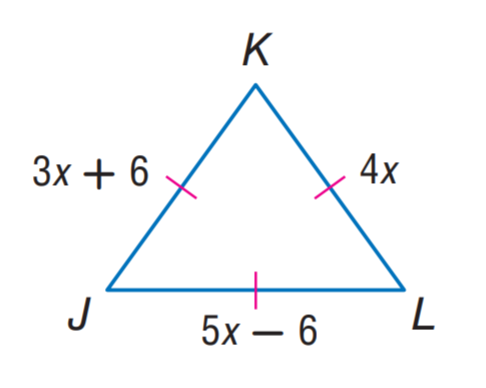Answer the mathemtical geometry problem and directly provide the correct option letter.
Question: Find K L.
Choices: A: 6 B: 18 C: 24 D: 42 C 